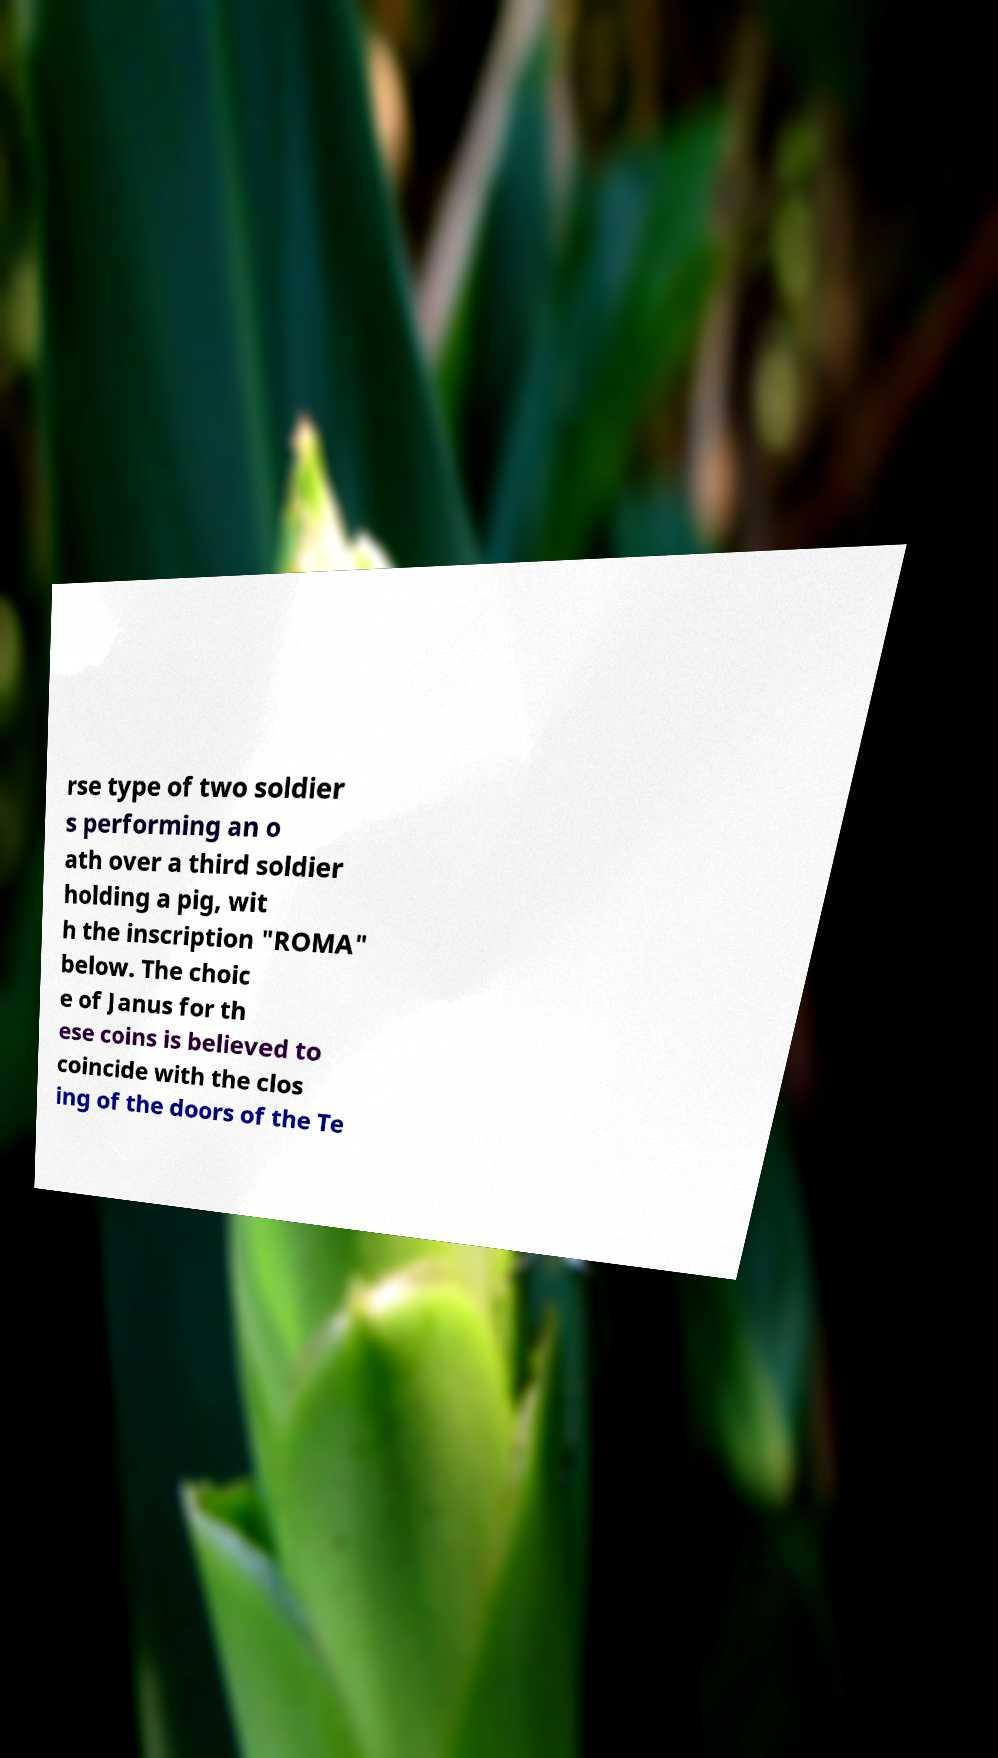For documentation purposes, I need the text within this image transcribed. Could you provide that? rse type of two soldier s performing an o ath over a third soldier holding a pig, wit h the inscription "ROMA" below. The choic e of Janus for th ese coins is believed to coincide with the clos ing of the doors of the Te 